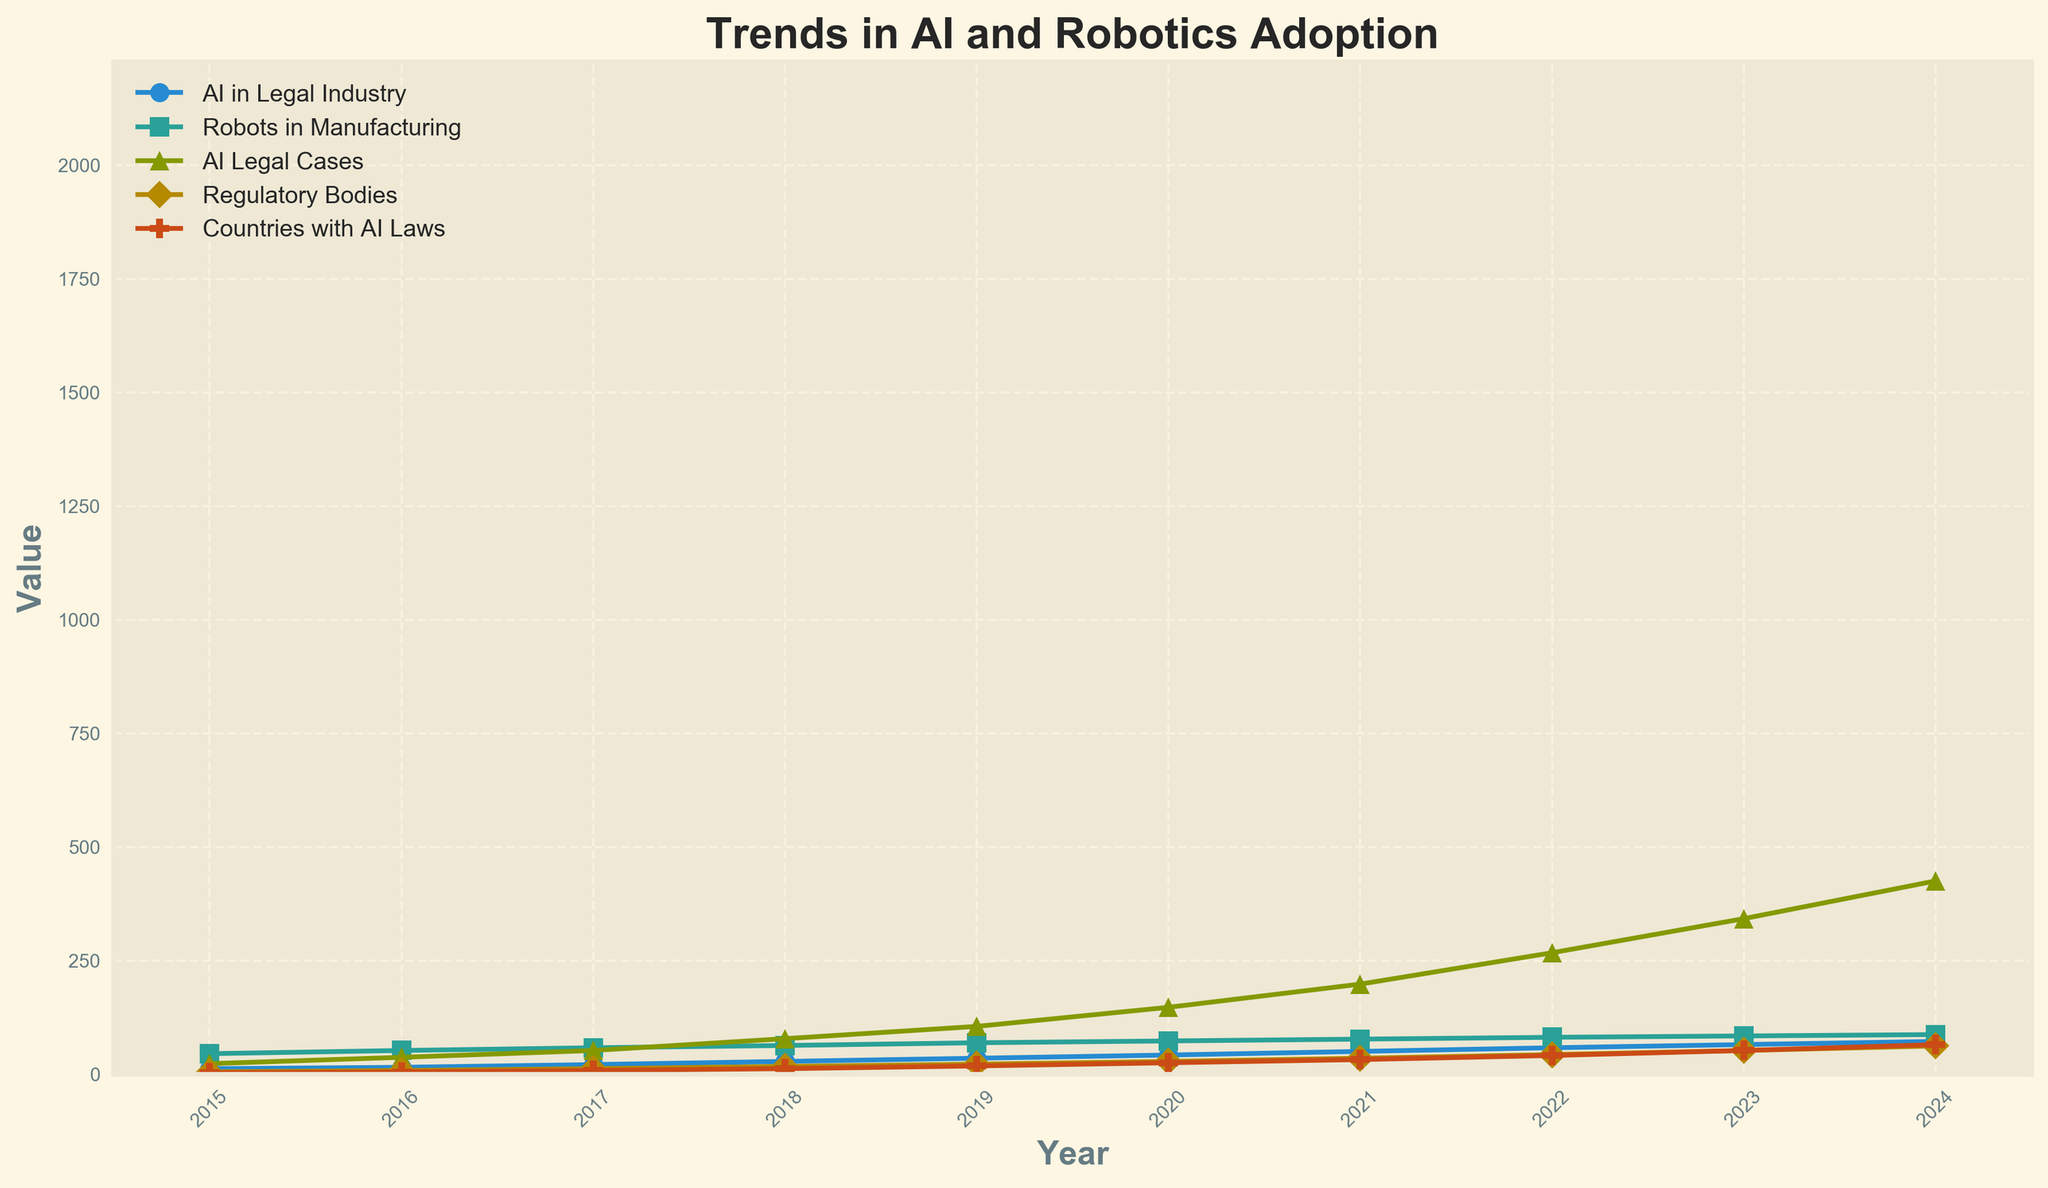What trend can be observed in AI adoption in the legal industry between 2015 and 2024? By examining the line representing AI adoption in the legal industry, which steadily increases from 12% in 2015 to 72% in 2024, we observe a consistent upward trend.
Answer: Consistent upward trend In what year did AI-related legal cases surpass 100 for the first time? By locating the "AI Legal Cases" line, we see it crosses the 100 mark between 2018 and 2019. Specifically, it reaches 105 in 2019.
Answer: 2019 How many regulatory bodies were addressing AI in 2021? By referring to the "Regulatory Bodies" line for the year 2021, it indicates that there were 35 regulatory bodies addressing AI.
Answer: 35 By what percentage did AI adoption in the legal industry grow from 2017 to 2018? The AI adoption grew from 21% in 2017 to 28% in 2018. The percentage increase is calculated as ((28 - 21) / 21) * 100 = 33.33%.
Answer: 33.33% Which category saw the steepest increase between 2015 and 2024? Observing all lines, the "AI-related Legal Cases" increased the most steeply, from 23 cases in 2015 to 425 cases in 2024.
Answer: AI-related Legal Cases Compare the adoption rates of robots in manufacturing and AI in the legal industry in the year 2020. In 2020, the adoption rate for robots in manufacturing was 73%, whereas it was 42% for AI in the legal industry.
Answer: Robots in manufacturing: 73%, AI in legal industry: 42% How many more countries had AI legislation in 2023 compared to 2016? The number of countries with AI legislation in 2023 was 52, and in 2016 it was 5. The difference is 52 - 5 = 47 more countries.
Answer: 47 What's the median number of countries with AI legislation from 2015 to 2024? The sorted data points for each year are: 3, 5, 8, 12, 18, 25, 32, 41, 52, 65. The median is calculated as the average of the 5th and 6th values: (18 + 25) / 2 = 21.5.
Answer: 21.5 Between which years did the adoption rate of AI in the legal industry see the highest annual increase? By comparing annual increments, the highest increase occurred from 2022 (58%) to 2023 (65%), an increment of 7 percentage points.
Answer: From 2022 to 2023 What visual feature differentiates the line representing countries with AI legislation? The line for "Countries with AI Laws" uses a "P" marker, making it visually distinct.
Answer: "P" marker 